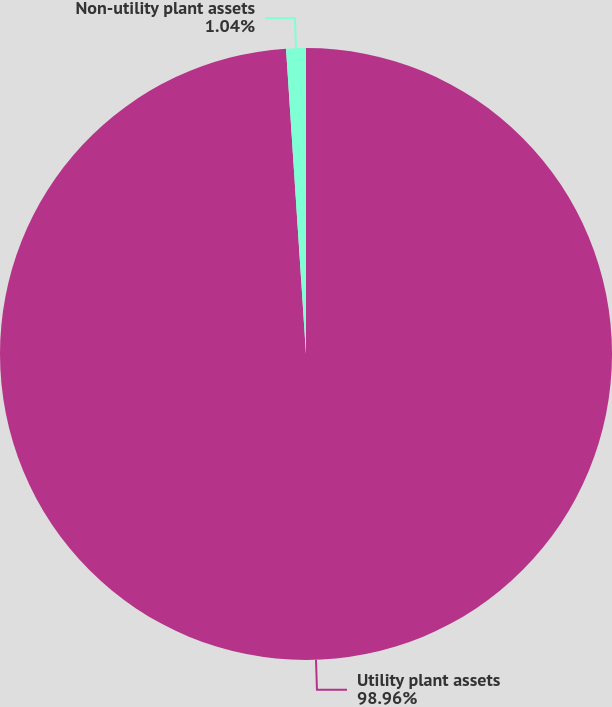Convert chart. <chart><loc_0><loc_0><loc_500><loc_500><pie_chart><fcel>Utility plant assets<fcel>Non-utility plant assets<nl><fcel>98.96%<fcel>1.04%<nl></chart> 